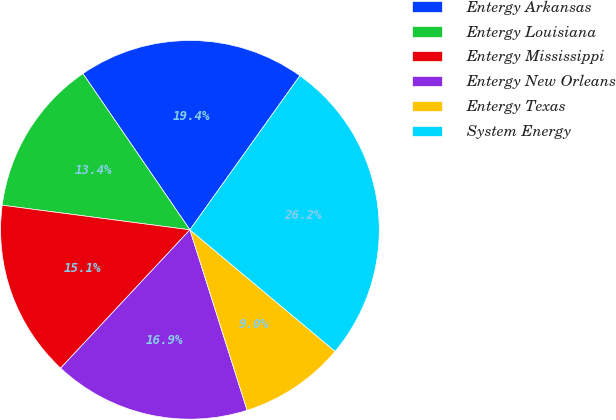Convert chart to OTSL. <chart><loc_0><loc_0><loc_500><loc_500><pie_chart><fcel>Entergy Arkansas<fcel>Entergy Louisiana<fcel>Entergy Mississippi<fcel>Entergy New Orleans<fcel>Entergy Texas<fcel>System Energy<nl><fcel>19.42%<fcel>13.37%<fcel>15.11%<fcel>16.85%<fcel>9.02%<fcel>26.23%<nl></chart> 